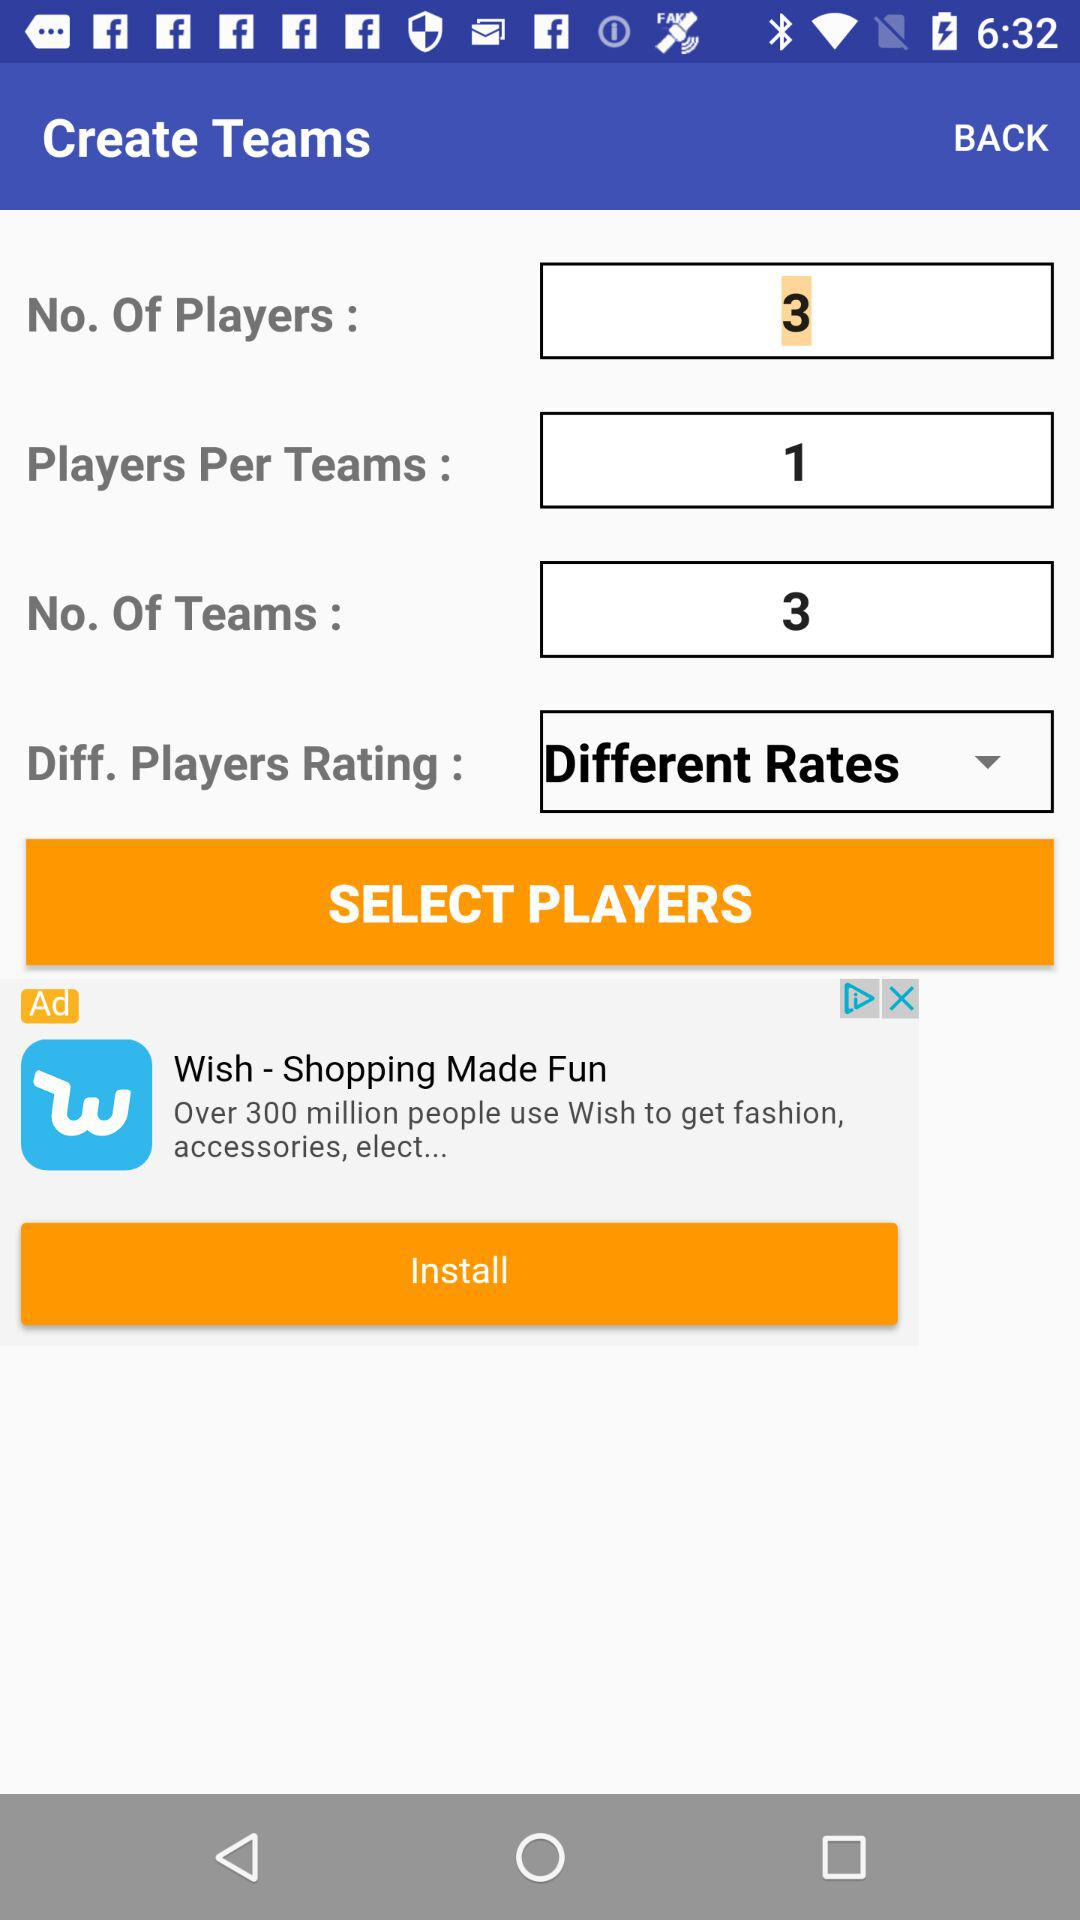What are the names of the selected players?
When the provided information is insufficient, respond with <no answer>. <no answer> 